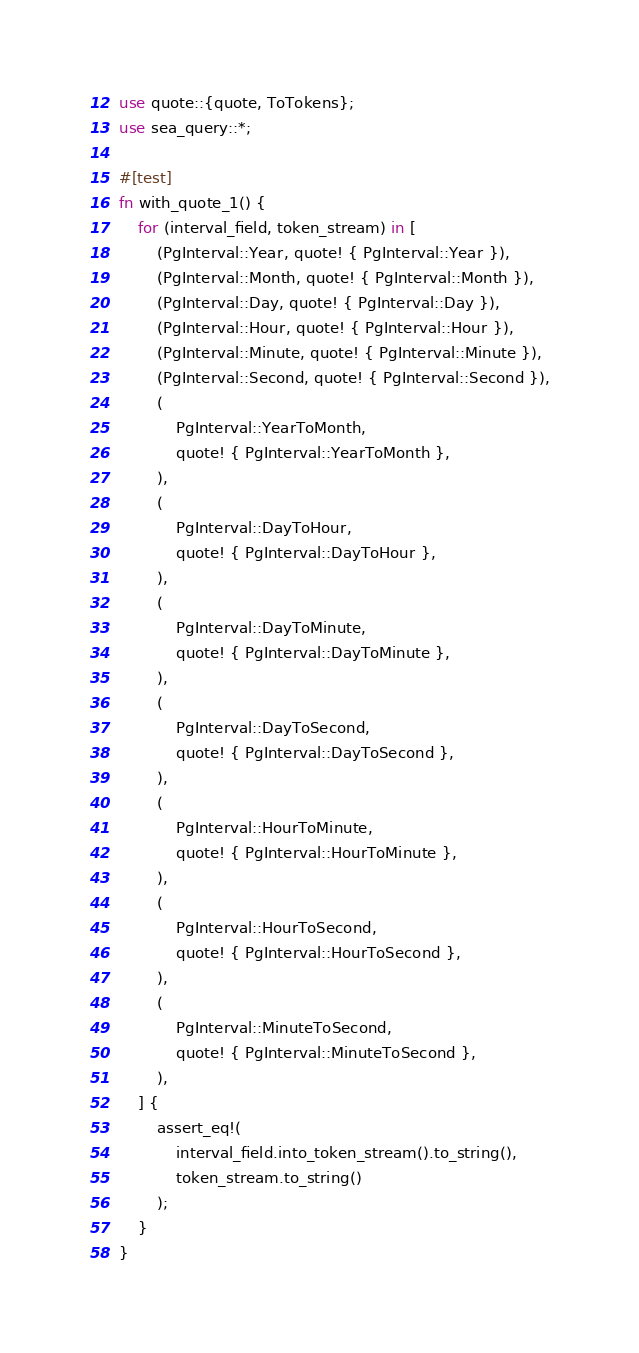<code> <loc_0><loc_0><loc_500><loc_500><_Rust_>use quote::{quote, ToTokens};
use sea_query::*;

#[test]
fn with_quote_1() {
    for (interval_field, token_stream) in [
        (PgInterval::Year, quote! { PgInterval::Year }),
        (PgInterval::Month, quote! { PgInterval::Month }),
        (PgInterval::Day, quote! { PgInterval::Day }),
        (PgInterval::Hour, quote! { PgInterval::Hour }),
        (PgInterval::Minute, quote! { PgInterval::Minute }),
        (PgInterval::Second, quote! { PgInterval::Second }),
        (
            PgInterval::YearToMonth,
            quote! { PgInterval::YearToMonth },
        ),
        (
            PgInterval::DayToHour,
            quote! { PgInterval::DayToHour },
        ),
        (
            PgInterval::DayToMinute,
            quote! { PgInterval::DayToMinute },
        ),
        (
            PgInterval::DayToSecond,
            quote! { PgInterval::DayToSecond },
        ),
        (
            PgInterval::HourToMinute,
            quote! { PgInterval::HourToMinute },
        ),
        (
            PgInterval::HourToSecond,
            quote! { PgInterval::HourToSecond },
        ),
        (
            PgInterval::MinuteToSecond,
            quote! { PgInterval::MinuteToSecond },
        ),
    ] {
        assert_eq!(
            interval_field.into_token_stream().to_string(),
            token_stream.to_string()
        );
    }
}
</code> 